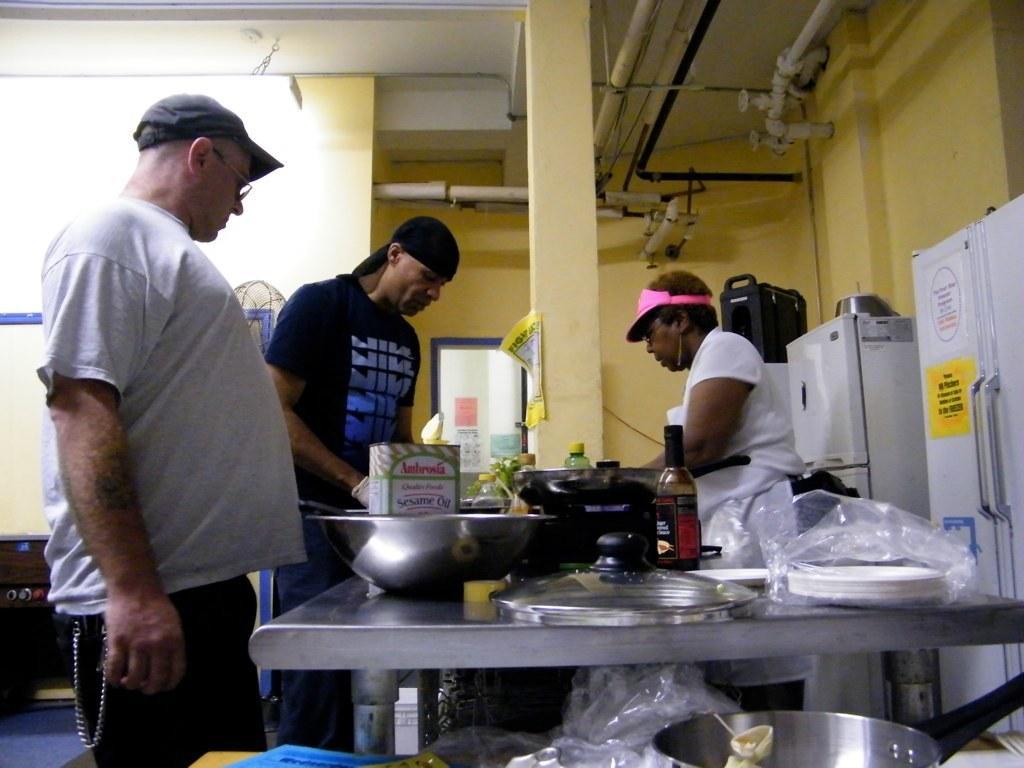Describe this image in one or two sentences. This image is taken inside a kitchen. In this image there are three men standing on the floor. In the right side of the image there are two refrigerators and a table with many things on top of it. In the background there is a wall, pillar and pipe lines. 